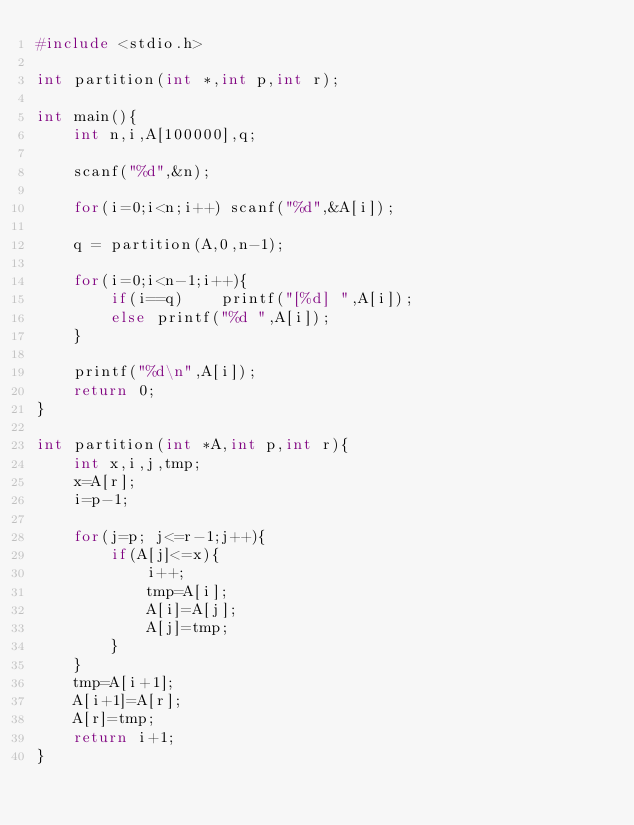<code> <loc_0><loc_0><loc_500><loc_500><_C_>#include <stdio.h>

int partition(int *,int p,int r);

int main(){
    int n,i,A[100000],q;

    scanf("%d",&n);

    for(i=0;i<n;i++) scanf("%d",&A[i]);

    q = partition(A,0,n-1);

    for(i=0;i<n-1;i++){
        if(i==q)    printf("[%d] ",A[i]);
        else printf("%d ",A[i]);
    }

    printf("%d\n",A[i]);
    return 0;
}

int partition(int *A,int p,int r){
    int x,i,j,tmp;
    x=A[r];
    i=p-1;

    for(j=p; j<=r-1;j++){
        if(A[j]<=x){
            i++;
            tmp=A[i];
            A[i]=A[j];
            A[j]=tmp;
        }
    }
    tmp=A[i+1];
    A[i+1]=A[r];
    A[r]=tmp;
    return i+1;
}
</code> 